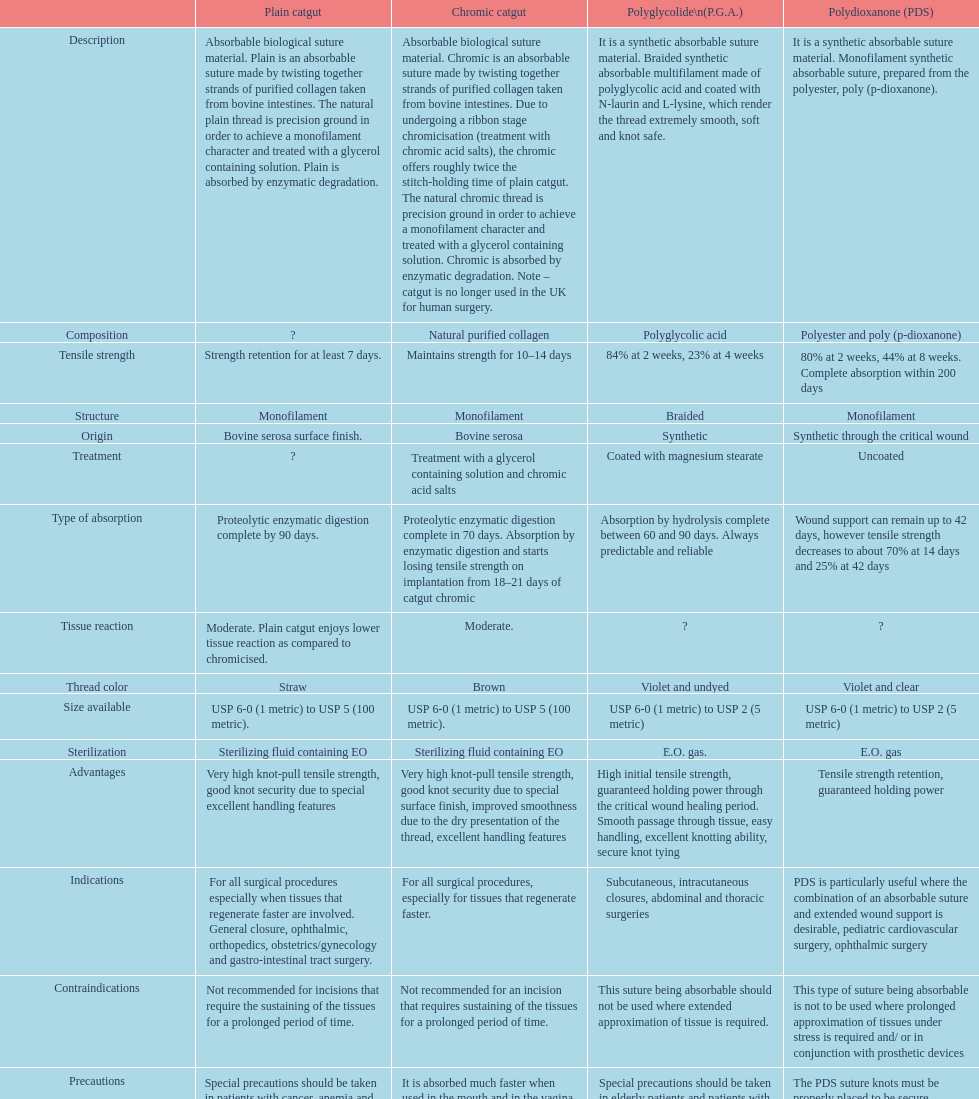The simple catgut retains its durability for a minimum of how many days? Strength retention for at least 7 days. 